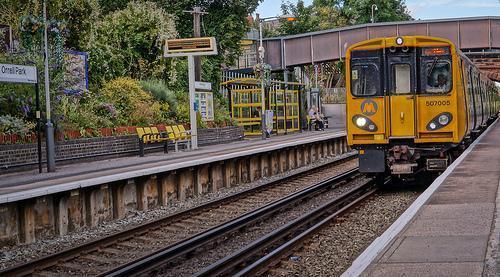How many trains are in the photo?
Give a very brief answer. 1. 